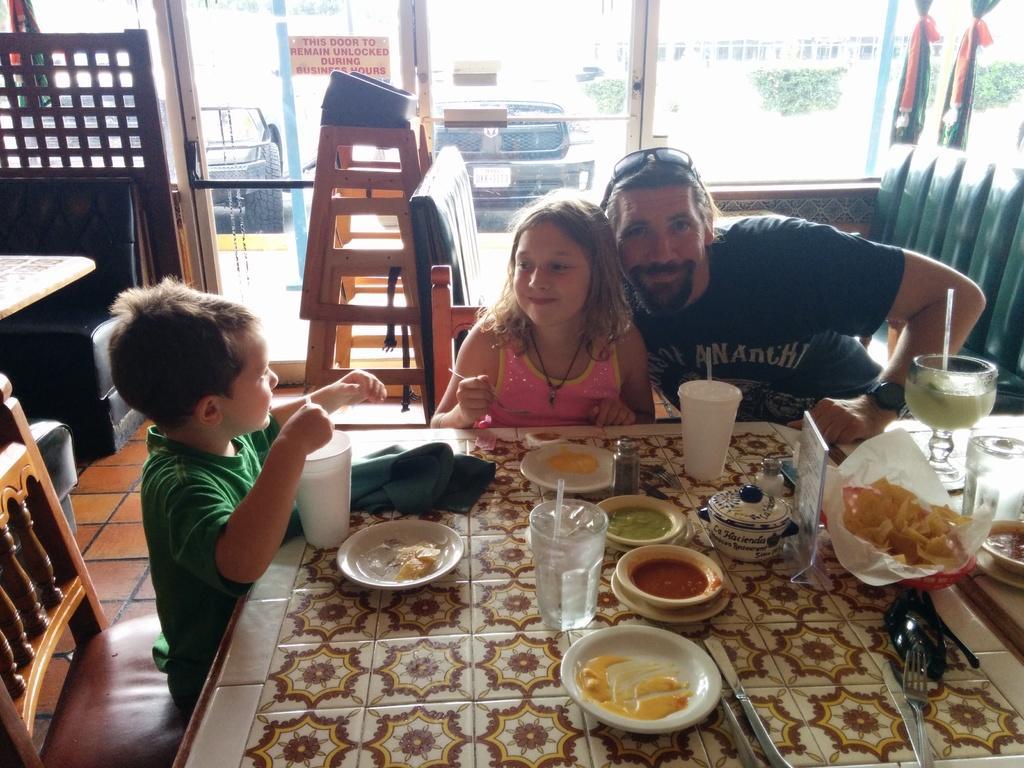Can you describe this image briefly? This picture looks like an inside view of a restaurant. there is man and two kids. they are sitting on chairs at the table. The man wore a black T-shirt and there is some text on it. He have a french beard and is smiling for the photograph. The girl is smiling looking at the boy and is holding a spoon. The boy beside her wore a green T-shirt and he is also looking at her. On the table there is food in the bowls and plates. There are spoons, forks and knives on the table. There are sauces in the bowl. Behind them there are couches and small ladder. In background there is a glass door, cars bushes, building and flags. On the glass door there is poster sticked to it.  